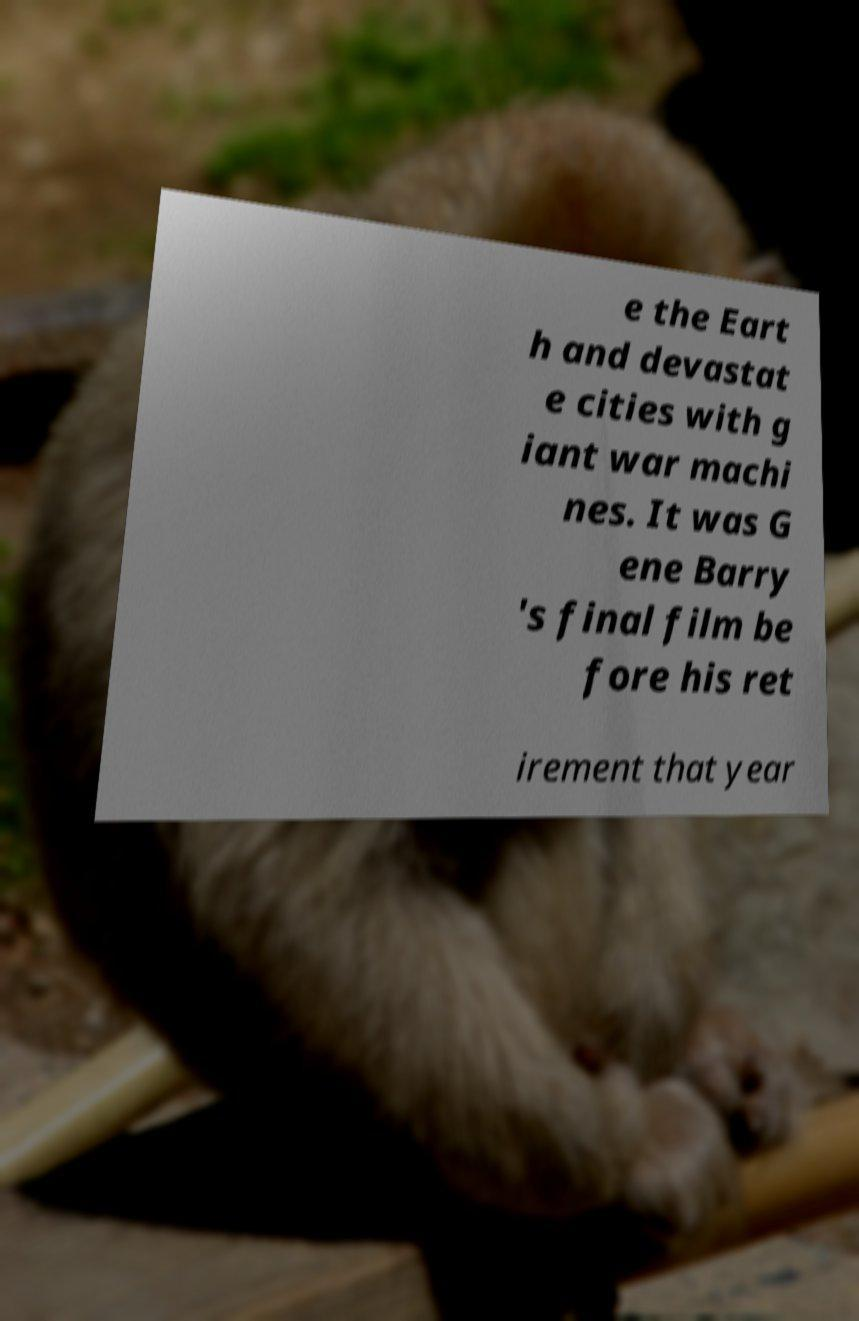Please identify and transcribe the text found in this image. e the Eart h and devastat e cities with g iant war machi nes. It was G ene Barry 's final film be fore his ret irement that year 